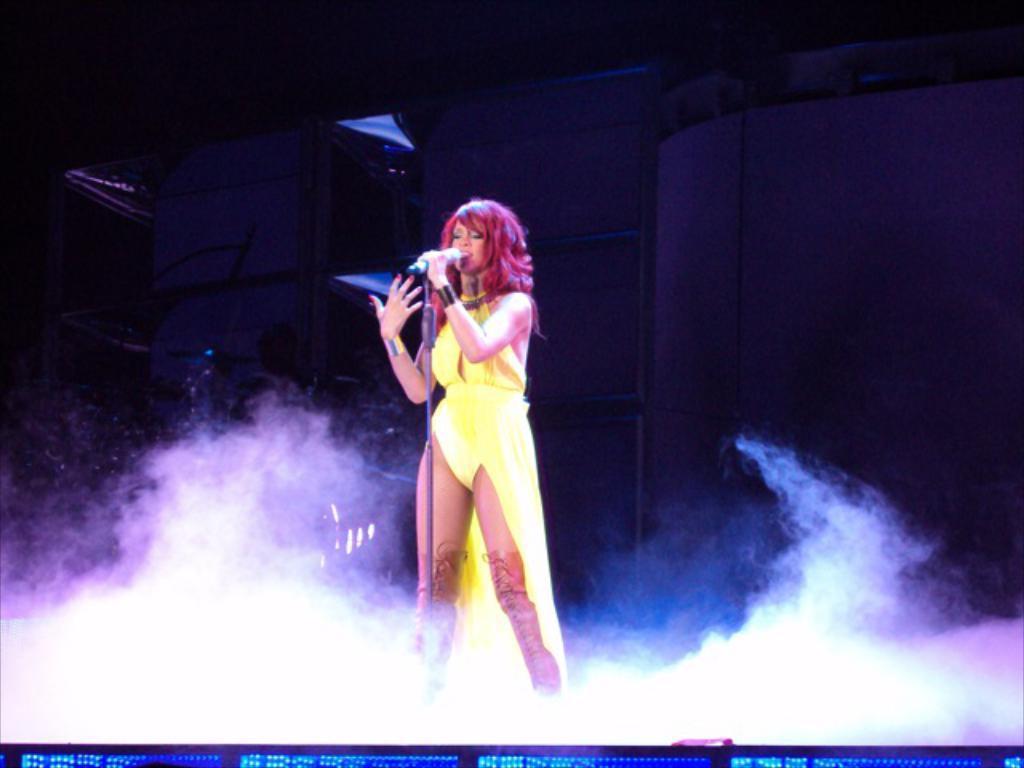In one or two sentences, can you explain what this image depicts? There is a lady holding a mic with mic stand. At the bottom there is smoke. In the back there is a wall and it is dark. 